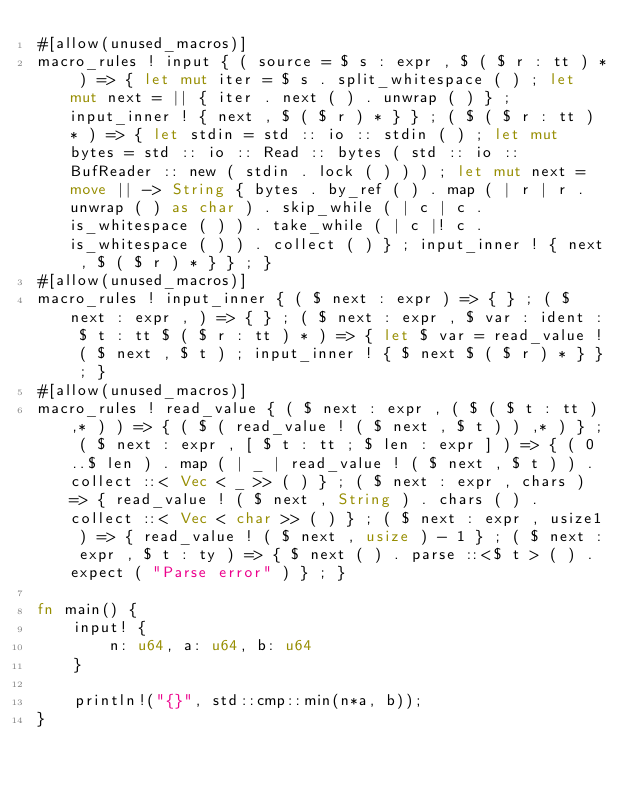<code> <loc_0><loc_0><loc_500><loc_500><_Rust_>#[allow(unused_macros)]
macro_rules ! input { ( source = $ s : expr , $ ( $ r : tt ) * ) => { let mut iter = $ s . split_whitespace ( ) ; let mut next = || { iter . next ( ) . unwrap ( ) } ; input_inner ! { next , $ ( $ r ) * } } ; ( $ ( $ r : tt ) * ) => { let stdin = std :: io :: stdin ( ) ; let mut bytes = std :: io :: Read :: bytes ( std :: io :: BufReader :: new ( stdin . lock ( ) ) ) ; let mut next = move || -> String { bytes . by_ref ( ) . map ( | r | r . unwrap ( ) as char ) . skip_while ( | c | c . is_whitespace ( ) ) . take_while ( | c |! c . is_whitespace ( ) ) . collect ( ) } ; input_inner ! { next , $ ( $ r ) * } } ; }
#[allow(unused_macros)]
macro_rules ! input_inner { ( $ next : expr ) => { } ; ( $ next : expr , ) => { } ; ( $ next : expr , $ var : ident : $ t : tt $ ( $ r : tt ) * ) => { let $ var = read_value ! ( $ next , $ t ) ; input_inner ! { $ next $ ( $ r ) * } } ; }
#[allow(unused_macros)]
macro_rules ! read_value { ( $ next : expr , ( $ ( $ t : tt ) ,* ) ) => { ( $ ( read_value ! ( $ next , $ t ) ) ,* ) } ; ( $ next : expr , [ $ t : tt ; $ len : expr ] ) => { ( 0 ..$ len ) . map ( | _ | read_value ! ( $ next , $ t ) ) . collect ::< Vec < _ >> ( ) } ; ( $ next : expr , chars ) => { read_value ! ( $ next , String ) . chars ( ) . collect ::< Vec < char >> ( ) } ; ( $ next : expr , usize1 ) => { read_value ! ( $ next , usize ) - 1 } ; ( $ next : expr , $ t : ty ) => { $ next ( ) . parse ::<$ t > ( ) . expect ( "Parse error" ) } ; }

fn main() {
    input! {
        n: u64, a: u64, b: u64
    }

    println!("{}", std::cmp::min(n*a, b));
}</code> 